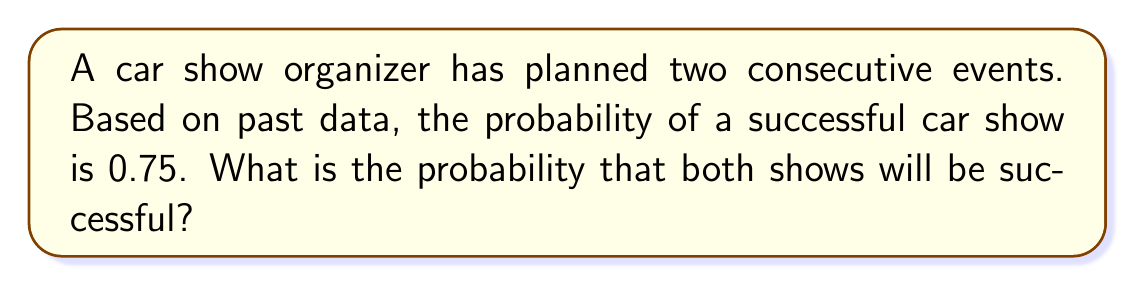Solve this math problem. To solve this problem, we need to apply the concept of independent events in probability theory.

Step 1: Identify the events
Let A be the event of the first show being successful
Let B be the event of the second show being successful

Step 2: Determine the probabilities
P(A) = 0.75 (probability of first show being successful)
P(B) = 0.75 (probability of second show being successful)

Step 3: Apply the multiplication rule for independent events
Since the success of one show doesn't affect the other, these events are independent. For independent events, the probability of both events occurring is the product of their individual probabilities.

$$P(A \text{ and } B) = P(A) \times P(B)$$

Step 4: Calculate the probability
$$P(A \text{ and } B) = 0.75 \times 0.75 = 0.5625$$

Therefore, the probability that both shows will be successful is 0.5625 or 56.25%.
Answer: 0.5625 